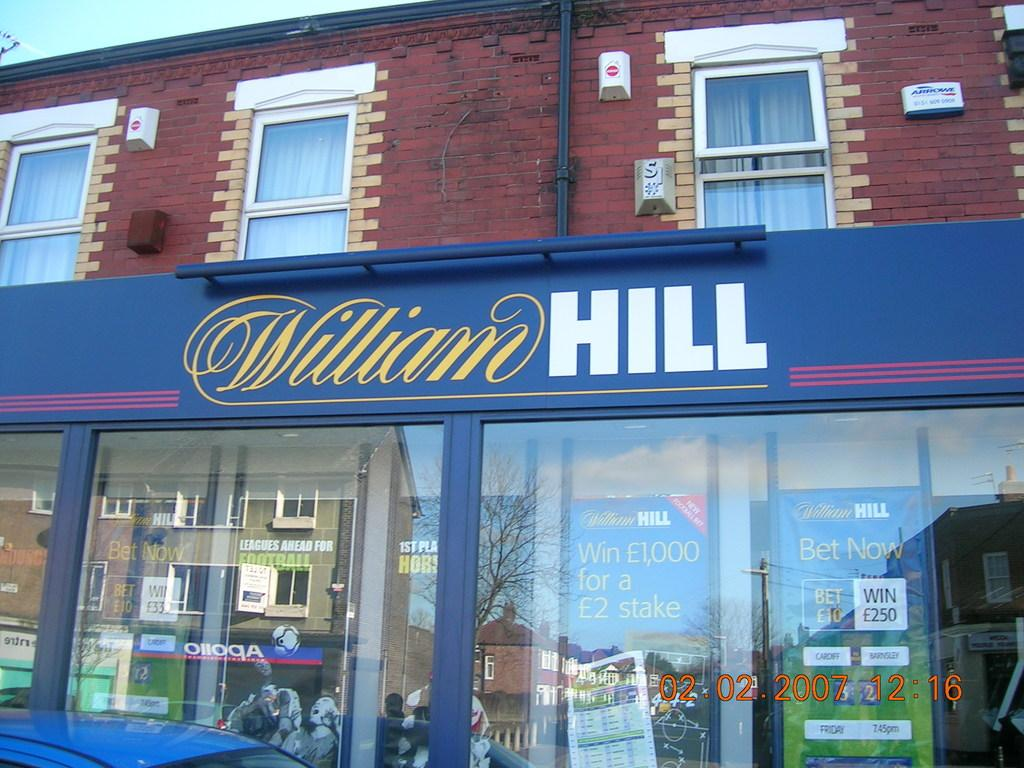What type of structure can be seen in the image? There is a building in the image. What can be seen in the sky in the image? The sky is visible in the image. What architectural feature is present in the building? There are windows in the image. What are the pipelines used for in the image? Pipelines are present in the image, but their purpose is not specified. What type of window treatment is visible in the image? There are curtains in the image. What type of vegetation is visible in the image? Trees are visible in the image. What type of signage is present in the image? Information boards are present in the image. What type of establishment is located in the building? There is a store in the image. What type of jelly is being sold in the store in the image? There is no indication of any jelly being sold in the store in the image. How many pigs are visible in the image? There are no pigs present in the image. 